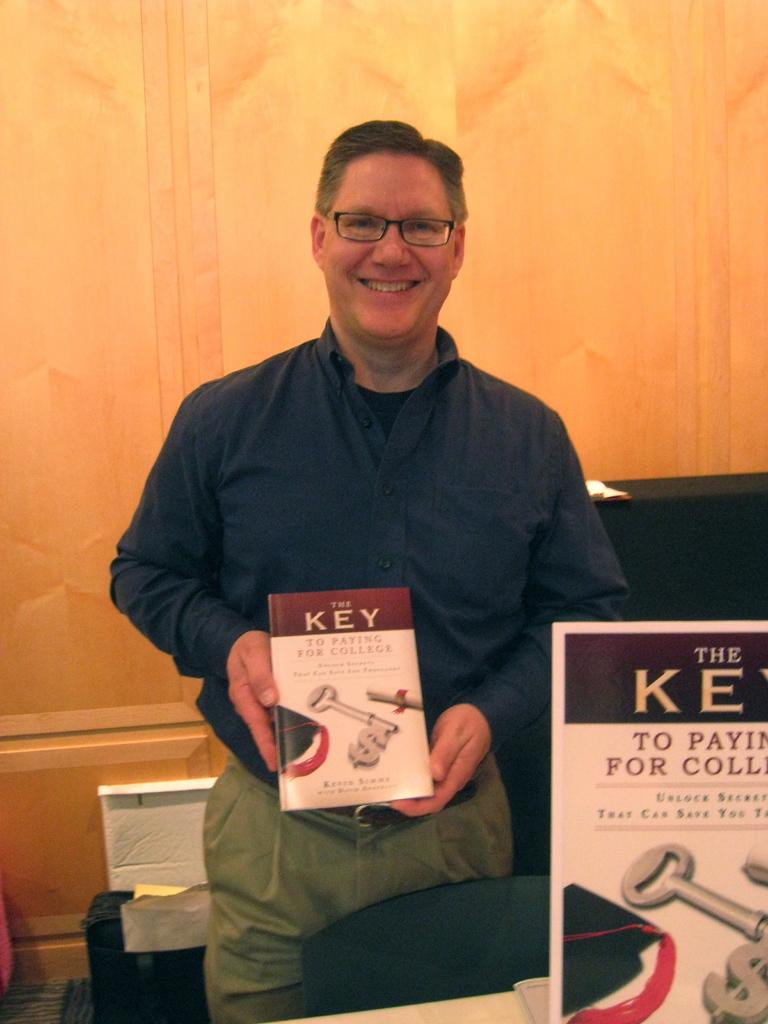What word is directly over the title of the book?
Give a very brief answer. The. 